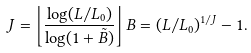Convert formula to latex. <formula><loc_0><loc_0><loc_500><loc_500>J = \left \lfloor \frac { \log ( L / L _ { 0 } ) } { \log ( 1 + \tilde { B } ) } \right \rfloor B = ( L / L _ { 0 } ) ^ { 1 / J } - 1 .</formula> 